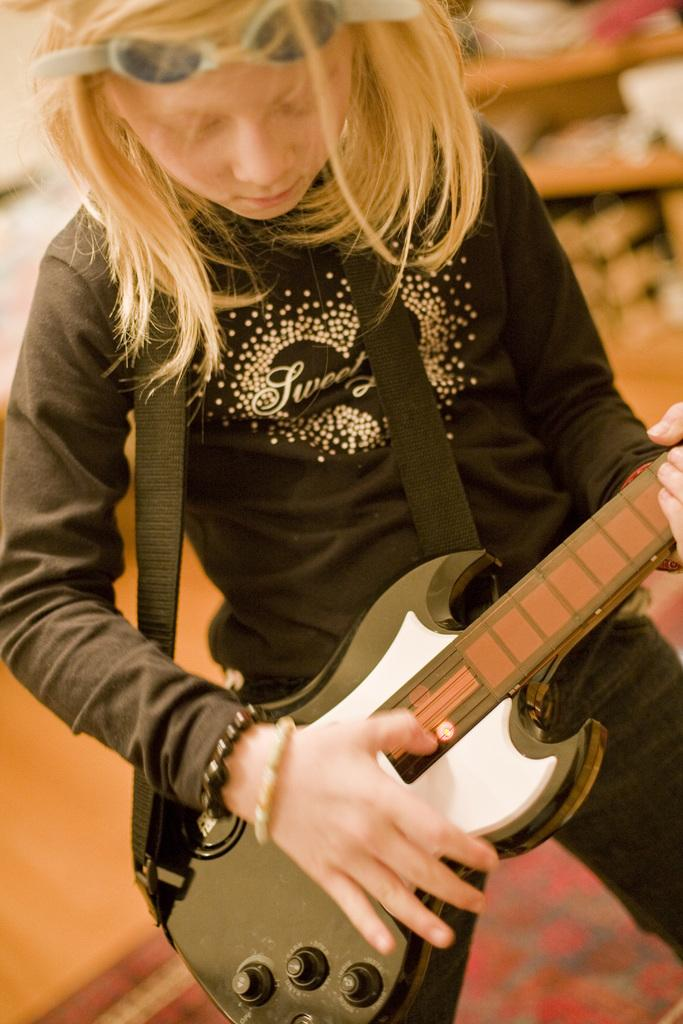What is the main subject of the image? There is a person in the image. What is the person holding in the image? The person is holding a guitar. How many pies can be seen on the table in the image? There is no table or pies present in the image; it features a person holding a guitar. What achievements has the person holding the guitar accomplished in the image? There is no information about the person's achievements in the image; it only shows them holding a guitar. 